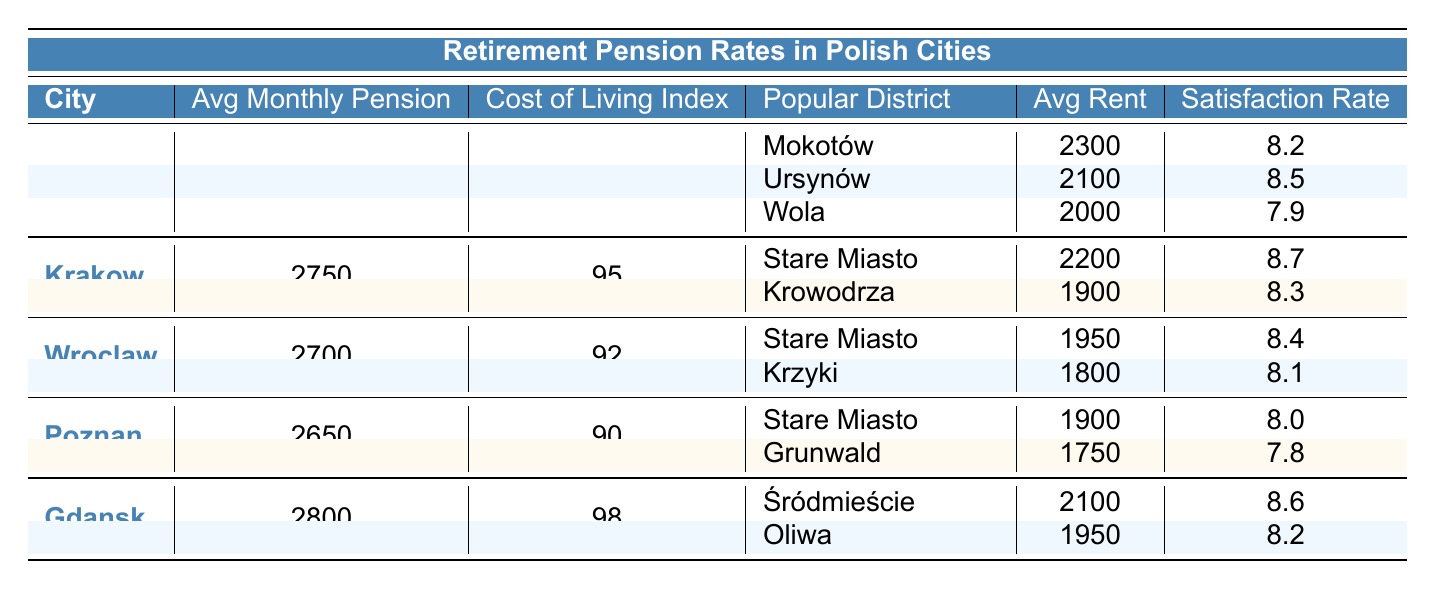What is the average monthly pension in Warsaw? The table directly states that the average monthly pension in Warsaw is 2850.
Answer: 2850 Which city has the highest average pension? Comparing the average pensions listed, Warsaw has 2850, Krakow has 2750, Wroclaw has 2700, Poznan has 2650, and Gdansk has 2800. Warsaw has the highest average pension.
Answer: Warsaw What is the cost of living index for Gdansk? The table shows that the cost of living index for Gdansk is 98.
Answer: 98 In which district of Warsaw do pensioners have the highest satisfaction rate? The satisfaction rates for the districts in Warsaw are 8.2 for Mokotów, 8.5 for Ursynów, and 7.9 for Wola. The highest satisfaction rate is in Ursynów with 8.5.
Answer: Ursynów How much lower is the average monthly pension in Poznan compared to Warsaw? The average monthly pension in Warsaw is 2850, while in Poznan it is 2650. The difference is calculated as 2850 - 2650 = 200.
Answer: 200 Which city has a lower average pension: Wroclaw or Poznan? Wroclaw has an average pension of 2700 and Poznan has 2650. Since 2650 is lower than 2700, Poznan has the lower average pension.
Answer: Poznan Is the average rent in Mokotów higher than in the Stare Miasto district of Krakow? The average rent in Mokotów is 2300 while in Stare Miasto it is 2200. Since 2300 is greater than 2200, Mokotów has higher rent.
Answer: Yes What is the average rent across the three districts listed for Warsaw? The average rent for Mokotów is 2300, for Ursynów is 2100, and for Wola is 2000. To find the average, add these values (2300 + 2100 + 2000 = 6400) and divide by 3 (6400 / 3 = 2133.33).
Answer: 2133.33 How does Gdansk's satisfaction rate in Śródmieście compare to Krakow's satisfaction rate in Stare Miasto? Gdansk's satisfaction rate in Śródmieście is 8.6, while Krakow's in Stare Miasto is 8.7. Since 8.6 is less than 8.7, Gdansk has a lower satisfaction rate.
Answer: Lower What is the total average rent of popular districts from all cities? The average rent for each city is added: Warsaw (2300 + 2100 + 2000 = 6400), Krakow (2200 + 1900 = 4100), Wroclaw (1950 + 1800 = 3750), Poznan (1900 + 1750 = 3650), and Gdansk (2100 + 1950 = 4050). Total = 6400 + 4100 + 3750 + 3650 + 4050 = 21750. There are 10 districts total so the average rent is 21750 / 10 = 2175.
Answer: 2175 